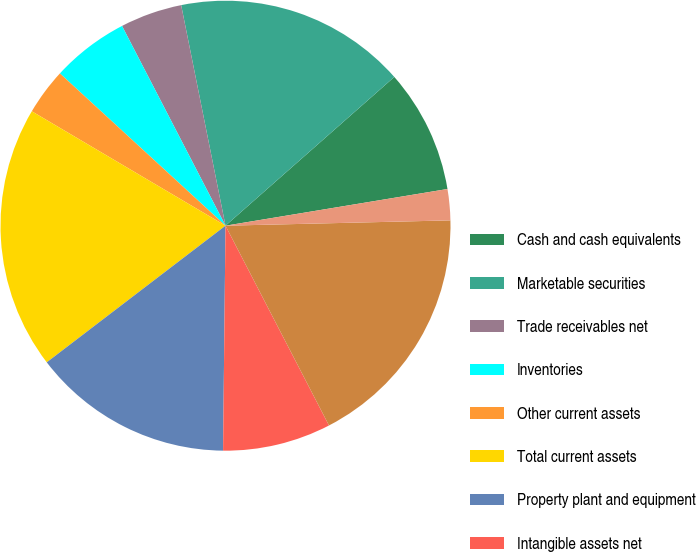Convert chart. <chart><loc_0><loc_0><loc_500><loc_500><pie_chart><fcel>Cash and cash equivalents<fcel>Marketable securities<fcel>Trade receivables net<fcel>Inventories<fcel>Other current assets<fcel>Total current assets<fcel>Property plant and equipment<fcel>Intangible assets net<fcel>Goodwill<fcel>Other assets<nl><fcel>8.89%<fcel>16.66%<fcel>4.45%<fcel>5.56%<fcel>3.34%<fcel>18.88%<fcel>14.44%<fcel>7.78%<fcel>17.77%<fcel>2.23%<nl></chart> 